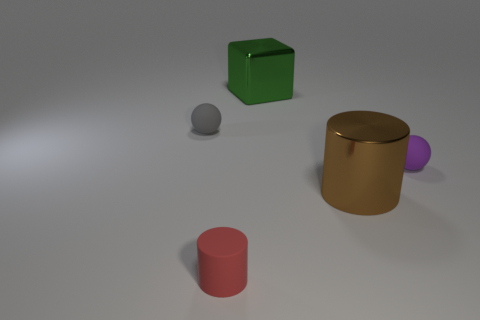Add 2 small brown cylinders. How many objects exist? 7 Subtract all spheres. How many objects are left? 3 Subtract all tiny gray metallic cylinders. Subtract all tiny matte cylinders. How many objects are left? 4 Add 1 green cubes. How many green cubes are left? 2 Add 5 large metallic blocks. How many large metallic blocks exist? 6 Subtract 0 cyan cylinders. How many objects are left? 5 